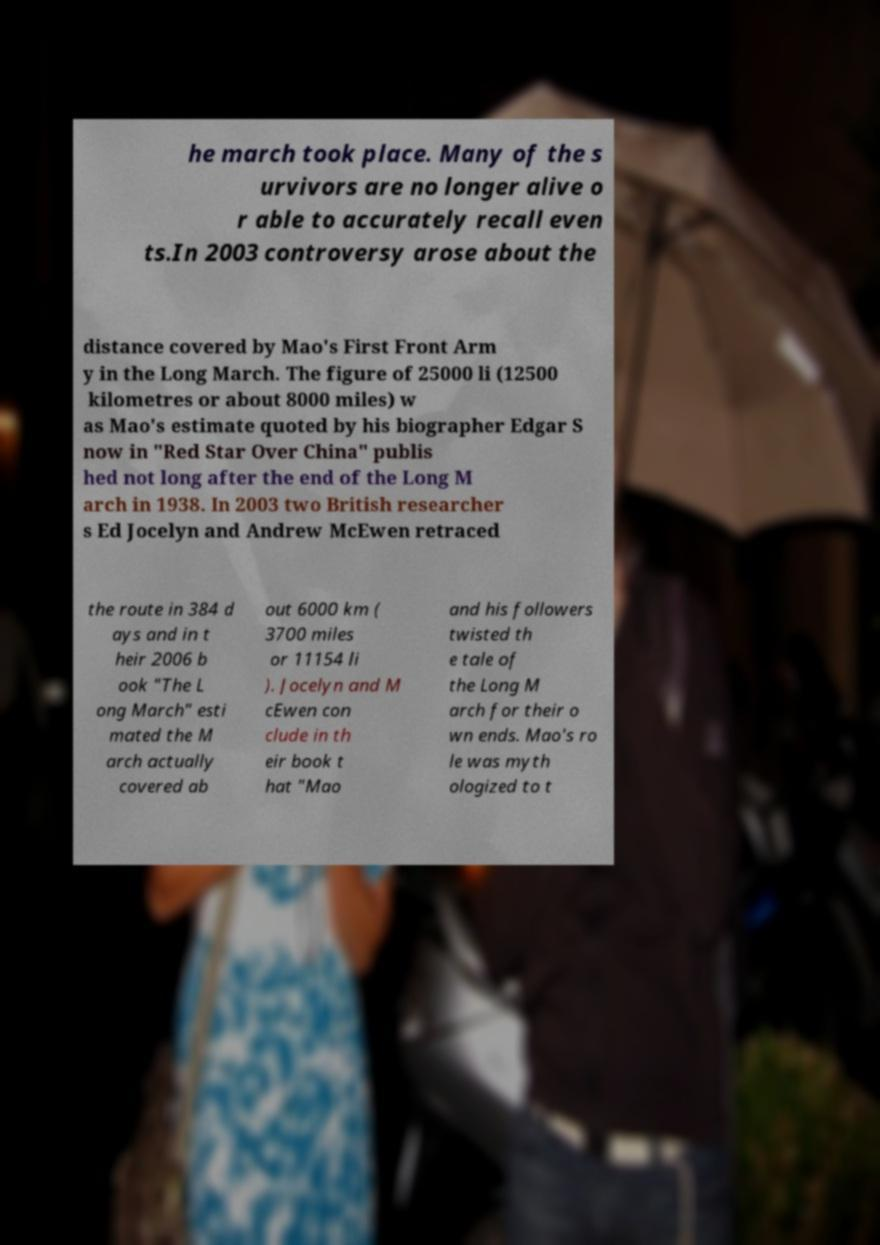For documentation purposes, I need the text within this image transcribed. Could you provide that? he march took place. Many of the s urvivors are no longer alive o r able to accurately recall even ts.In 2003 controversy arose about the distance covered by Mao's First Front Arm y in the Long March. The figure of 25000 li (12500 kilometres or about 8000 miles) w as Mao's estimate quoted by his biographer Edgar S now in "Red Star Over China" publis hed not long after the end of the Long M arch in 1938. In 2003 two British researcher s Ed Jocelyn and Andrew McEwen retraced the route in 384 d ays and in t heir 2006 b ook "The L ong March" esti mated the M arch actually covered ab out 6000 km ( 3700 miles or 11154 li ). Jocelyn and M cEwen con clude in th eir book t hat "Mao and his followers twisted th e tale of the Long M arch for their o wn ends. Mao's ro le was myth ologized to t 